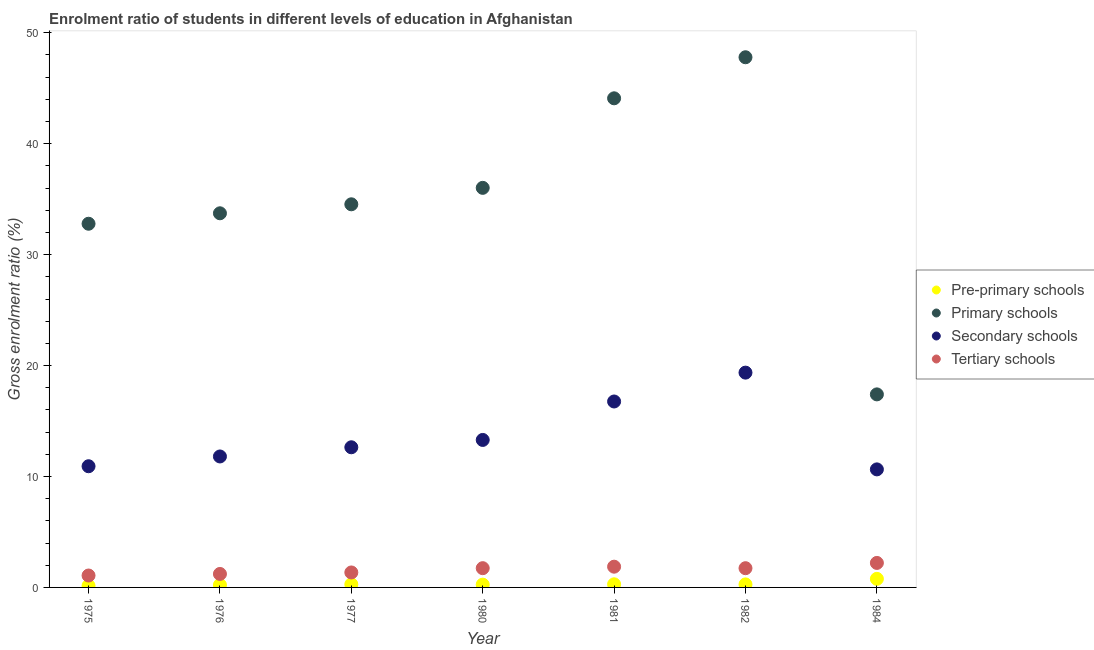How many different coloured dotlines are there?
Your answer should be compact. 4. What is the gross enrolment ratio in primary schools in 1984?
Make the answer very short. 17.4. Across all years, what is the maximum gross enrolment ratio in primary schools?
Keep it short and to the point. 47.8. Across all years, what is the minimum gross enrolment ratio in primary schools?
Offer a very short reply. 17.4. In which year was the gross enrolment ratio in tertiary schools minimum?
Your answer should be very brief. 1975. What is the total gross enrolment ratio in pre-primary schools in the graph?
Your response must be concise. 2.23. What is the difference between the gross enrolment ratio in primary schools in 1976 and that in 1980?
Your response must be concise. -2.29. What is the difference between the gross enrolment ratio in tertiary schools in 1980 and the gross enrolment ratio in primary schools in 1977?
Offer a terse response. -32.8. What is the average gross enrolment ratio in secondary schools per year?
Ensure brevity in your answer.  13.63. In the year 1980, what is the difference between the gross enrolment ratio in primary schools and gross enrolment ratio in secondary schools?
Make the answer very short. 22.73. What is the ratio of the gross enrolment ratio in tertiary schools in 1981 to that in 1982?
Offer a very short reply. 1.08. Is the gross enrolment ratio in primary schools in 1980 less than that in 1982?
Make the answer very short. Yes. What is the difference between the highest and the second highest gross enrolment ratio in tertiary schools?
Offer a very short reply. 0.34. What is the difference between the highest and the lowest gross enrolment ratio in primary schools?
Provide a succinct answer. 30.39. In how many years, is the gross enrolment ratio in secondary schools greater than the average gross enrolment ratio in secondary schools taken over all years?
Offer a very short reply. 2. Is it the case that in every year, the sum of the gross enrolment ratio in tertiary schools and gross enrolment ratio in primary schools is greater than the sum of gross enrolment ratio in secondary schools and gross enrolment ratio in pre-primary schools?
Offer a very short reply. No. Is it the case that in every year, the sum of the gross enrolment ratio in pre-primary schools and gross enrolment ratio in primary schools is greater than the gross enrolment ratio in secondary schools?
Your answer should be compact. Yes. Is the gross enrolment ratio in tertiary schools strictly less than the gross enrolment ratio in secondary schools over the years?
Your response must be concise. Yes. How many dotlines are there?
Your answer should be compact. 4. How many years are there in the graph?
Provide a short and direct response. 7. Does the graph contain any zero values?
Make the answer very short. No. Does the graph contain grids?
Give a very brief answer. No. Where does the legend appear in the graph?
Provide a short and direct response. Center right. How are the legend labels stacked?
Ensure brevity in your answer.  Vertical. What is the title of the graph?
Ensure brevity in your answer.  Enrolment ratio of students in different levels of education in Afghanistan. Does "UNRWA" appear as one of the legend labels in the graph?
Offer a terse response. No. What is the Gross enrolment ratio (%) in Pre-primary schools in 1975?
Provide a succinct answer. 0.15. What is the Gross enrolment ratio (%) of Primary schools in 1975?
Your answer should be compact. 32.79. What is the Gross enrolment ratio (%) of Secondary schools in 1975?
Give a very brief answer. 10.93. What is the Gross enrolment ratio (%) in Tertiary schools in 1975?
Provide a short and direct response. 1.07. What is the Gross enrolment ratio (%) of Pre-primary schools in 1976?
Provide a succinct answer. 0.22. What is the Gross enrolment ratio (%) in Primary schools in 1976?
Your answer should be very brief. 33.73. What is the Gross enrolment ratio (%) of Secondary schools in 1976?
Give a very brief answer. 11.81. What is the Gross enrolment ratio (%) in Tertiary schools in 1976?
Give a very brief answer. 1.22. What is the Gross enrolment ratio (%) in Pre-primary schools in 1977?
Give a very brief answer. 0.28. What is the Gross enrolment ratio (%) of Primary schools in 1977?
Your answer should be compact. 34.54. What is the Gross enrolment ratio (%) of Secondary schools in 1977?
Provide a short and direct response. 12.63. What is the Gross enrolment ratio (%) in Tertiary schools in 1977?
Your response must be concise. 1.35. What is the Gross enrolment ratio (%) of Pre-primary schools in 1980?
Provide a short and direct response. 0.25. What is the Gross enrolment ratio (%) of Primary schools in 1980?
Your answer should be very brief. 36.02. What is the Gross enrolment ratio (%) in Secondary schools in 1980?
Your response must be concise. 13.3. What is the Gross enrolment ratio (%) of Tertiary schools in 1980?
Ensure brevity in your answer.  1.74. What is the Gross enrolment ratio (%) in Pre-primary schools in 1981?
Give a very brief answer. 0.28. What is the Gross enrolment ratio (%) in Primary schools in 1981?
Offer a very short reply. 44.1. What is the Gross enrolment ratio (%) in Secondary schools in 1981?
Give a very brief answer. 16.76. What is the Gross enrolment ratio (%) in Tertiary schools in 1981?
Your answer should be compact. 1.87. What is the Gross enrolment ratio (%) of Pre-primary schools in 1982?
Your answer should be compact. 0.27. What is the Gross enrolment ratio (%) in Primary schools in 1982?
Offer a very short reply. 47.8. What is the Gross enrolment ratio (%) in Secondary schools in 1982?
Your answer should be compact. 19.36. What is the Gross enrolment ratio (%) of Tertiary schools in 1982?
Your answer should be very brief. 1.73. What is the Gross enrolment ratio (%) in Pre-primary schools in 1984?
Provide a succinct answer. 0.77. What is the Gross enrolment ratio (%) of Primary schools in 1984?
Provide a succinct answer. 17.4. What is the Gross enrolment ratio (%) in Secondary schools in 1984?
Make the answer very short. 10.64. What is the Gross enrolment ratio (%) in Tertiary schools in 1984?
Ensure brevity in your answer.  2.21. Across all years, what is the maximum Gross enrolment ratio (%) in Pre-primary schools?
Provide a short and direct response. 0.77. Across all years, what is the maximum Gross enrolment ratio (%) of Primary schools?
Offer a terse response. 47.8. Across all years, what is the maximum Gross enrolment ratio (%) in Secondary schools?
Keep it short and to the point. 19.36. Across all years, what is the maximum Gross enrolment ratio (%) in Tertiary schools?
Provide a succinct answer. 2.21. Across all years, what is the minimum Gross enrolment ratio (%) of Pre-primary schools?
Keep it short and to the point. 0.15. Across all years, what is the minimum Gross enrolment ratio (%) of Primary schools?
Offer a terse response. 17.4. Across all years, what is the minimum Gross enrolment ratio (%) of Secondary schools?
Give a very brief answer. 10.64. Across all years, what is the minimum Gross enrolment ratio (%) in Tertiary schools?
Your response must be concise. 1.07. What is the total Gross enrolment ratio (%) of Pre-primary schools in the graph?
Ensure brevity in your answer.  2.23. What is the total Gross enrolment ratio (%) in Primary schools in the graph?
Your response must be concise. 246.37. What is the total Gross enrolment ratio (%) in Secondary schools in the graph?
Your answer should be compact. 95.43. What is the total Gross enrolment ratio (%) of Tertiary schools in the graph?
Ensure brevity in your answer.  11.19. What is the difference between the Gross enrolment ratio (%) of Pre-primary schools in 1975 and that in 1976?
Keep it short and to the point. -0.07. What is the difference between the Gross enrolment ratio (%) of Primary schools in 1975 and that in 1976?
Offer a terse response. -0.94. What is the difference between the Gross enrolment ratio (%) of Secondary schools in 1975 and that in 1976?
Provide a succinct answer. -0.88. What is the difference between the Gross enrolment ratio (%) in Tertiary schools in 1975 and that in 1976?
Keep it short and to the point. -0.14. What is the difference between the Gross enrolment ratio (%) of Pre-primary schools in 1975 and that in 1977?
Give a very brief answer. -0.13. What is the difference between the Gross enrolment ratio (%) of Primary schools in 1975 and that in 1977?
Offer a terse response. -1.75. What is the difference between the Gross enrolment ratio (%) of Secondary schools in 1975 and that in 1977?
Provide a short and direct response. -1.71. What is the difference between the Gross enrolment ratio (%) in Tertiary schools in 1975 and that in 1977?
Offer a very short reply. -0.28. What is the difference between the Gross enrolment ratio (%) in Pre-primary schools in 1975 and that in 1980?
Provide a succinct answer. -0.1. What is the difference between the Gross enrolment ratio (%) of Primary schools in 1975 and that in 1980?
Provide a succinct answer. -3.24. What is the difference between the Gross enrolment ratio (%) of Secondary schools in 1975 and that in 1980?
Make the answer very short. -2.37. What is the difference between the Gross enrolment ratio (%) in Tertiary schools in 1975 and that in 1980?
Your answer should be compact. -0.66. What is the difference between the Gross enrolment ratio (%) of Pre-primary schools in 1975 and that in 1981?
Ensure brevity in your answer.  -0.13. What is the difference between the Gross enrolment ratio (%) of Primary schools in 1975 and that in 1981?
Your response must be concise. -11.31. What is the difference between the Gross enrolment ratio (%) in Secondary schools in 1975 and that in 1981?
Make the answer very short. -5.84. What is the difference between the Gross enrolment ratio (%) of Tertiary schools in 1975 and that in 1981?
Make the answer very short. -0.8. What is the difference between the Gross enrolment ratio (%) of Pre-primary schools in 1975 and that in 1982?
Offer a very short reply. -0.13. What is the difference between the Gross enrolment ratio (%) of Primary schools in 1975 and that in 1982?
Provide a short and direct response. -15.01. What is the difference between the Gross enrolment ratio (%) in Secondary schools in 1975 and that in 1982?
Your answer should be compact. -8.44. What is the difference between the Gross enrolment ratio (%) of Tertiary schools in 1975 and that in 1982?
Keep it short and to the point. -0.66. What is the difference between the Gross enrolment ratio (%) of Pre-primary schools in 1975 and that in 1984?
Give a very brief answer. -0.62. What is the difference between the Gross enrolment ratio (%) in Primary schools in 1975 and that in 1984?
Provide a short and direct response. 15.38. What is the difference between the Gross enrolment ratio (%) of Secondary schools in 1975 and that in 1984?
Provide a succinct answer. 0.28. What is the difference between the Gross enrolment ratio (%) of Tertiary schools in 1975 and that in 1984?
Keep it short and to the point. -1.13. What is the difference between the Gross enrolment ratio (%) in Pre-primary schools in 1976 and that in 1977?
Your answer should be very brief. -0.06. What is the difference between the Gross enrolment ratio (%) in Primary schools in 1976 and that in 1977?
Provide a succinct answer. -0.81. What is the difference between the Gross enrolment ratio (%) of Secondary schools in 1976 and that in 1977?
Keep it short and to the point. -0.83. What is the difference between the Gross enrolment ratio (%) of Tertiary schools in 1976 and that in 1977?
Ensure brevity in your answer.  -0.13. What is the difference between the Gross enrolment ratio (%) of Pre-primary schools in 1976 and that in 1980?
Keep it short and to the point. -0.03. What is the difference between the Gross enrolment ratio (%) of Primary schools in 1976 and that in 1980?
Your answer should be compact. -2.29. What is the difference between the Gross enrolment ratio (%) of Secondary schools in 1976 and that in 1980?
Keep it short and to the point. -1.49. What is the difference between the Gross enrolment ratio (%) in Tertiary schools in 1976 and that in 1980?
Your answer should be compact. -0.52. What is the difference between the Gross enrolment ratio (%) in Pre-primary schools in 1976 and that in 1981?
Offer a terse response. -0.06. What is the difference between the Gross enrolment ratio (%) in Primary schools in 1976 and that in 1981?
Offer a terse response. -10.37. What is the difference between the Gross enrolment ratio (%) in Secondary schools in 1976 and that in 1981?
Offer a terse response. -4.96. What is the difference between the Gross enrolment ratio (%) of Tertiary schools in 1976 and that in 1981?
Give a very brief answer. -0.65. What is the difference between the Gross enrolment ratio (%) in Pre-primary schools in 1976 and that in 1982?
Offer a very short reply. -0.05. What is the difference between the Gross enrolment ratio (%) of Primary schools in 1976 and that in 1982?
Give a very brief answer. -14.07. What is the difference between the Gross enrolment ratio (%) of Secondary schools in 1976 and that in 1982?
Offer a very short reply. -7.56. What is the difference between the Gross enrolment ratio (%) of Tertiary schools in 1976 and that in 1982?
Keep it short and to the point. -0.52. What is the difference between the Gross enrolment ratio (%) in Pre-primary schools in 1976 and that in 1984?
Keep it short and to the point. -0.55. What is the difference between the Gross enrolment ratio (%) in Primary schools in 1976 and that in 1984?
Provide a succinct answer. 16.33. What is the difference between the Gross enrolment ratio (%) of Secondary schools in 1976 and that in 1984?
Make the answer very short. 1.16. What is the difference between the Gross enrolment ratio (%) in Tertiary schools in 1976 and that in 1984?
Offer a very short reply. -0.99. What is the difference between the Gross enrolment ratio (%) of Pre-primary schools in 1977 and that in 1980?
Your answer should be very brief. 0.03. What is the difference between the Gross enrolment ratio (%) of Primary schools in 1977 and that in 1980?
Provide a succinct answer. -1.48. What is the difference between the Gross enrolment ratio (%) of Secondary schools in 1977 and that in 1980?
Give a very brief answer. -0.66. What is the difference between the Gross enrolment ratio (%) of Tertiary schools in 1977 and that in 1980?
Your answer should be very brief. -0.39. What is the difference between the Gross enrolment ratio (%) of Pre-primary schools in 1977 and that in 1981?
Provide a succinct answer. -0. What is the difference between the Gross enrolment ratio (%) in Primary schools in 1977 and that in 1981?
Your answer should be compact. -9.56. What is the difference between the Gross enrolment ratio (%) of Secondary schools in 1977 and that in 1981?
Keep it short and to the point. -4.13. What is the difference between the Gross enrolment ratio (%) of Tertiary schools in 1977 and that in 1981?
Provide a succinct answer. -0.52. What is the difference between the Gross enrolment ratio (%) in Pre-primary schools in 1977 and that in 1982?
Your answer should be very brief. 0. What is the difference between the Gross enrolment ratio (%) of Primary schools in 1977 and that in 1982?
Ensure brevity in your answer.  -13.26. What is the difference between the Gross enrolment ratio (%) of Secondary schools in 1977 and that in 1982?
Provide a short and direct response. -6.73. What is the difference between the Gross enrolment ratio (%) of Tertiary schools in 1977 and that in 1982?
Offer a terse response. -0.38. What is the difference between the Gross enrolment ratio (%) of Pre-primary schools in 1977 and that in 1984?
Ensure brevity in your answer.  -0.5. What is the difference between the Gross enrolment ratio (%) of Primary schools in 1977 and that in 1984?
Provide a short and direct response. 17.14. What is the difference between the Gross enrolment ratio (%) in Secondary schools in 1977 and that in 1984?
Make the answer very short. 1.99. What is the difference between the Gross enrolment ratio (%) of Tertiary schools in 1977 and that in 1984?
Your response must be concise. -0.86. What is the difference between the Gross enrolment ratio (%) of Pre-primary schools in 1980 and that in 1981?
Your response must be concise. -0.03. What is the difference between the Gross enrolment ratio (%) of Primary schools in 1980 and that in 1981?
Your answer should be very brief. -8.07. What is the difference between the Gross enrolment ratio (%) in Secondary schools in 1980 and that in 1981?
Provide a short and direct response. -3.47. What is the difference between the Gross enrolment ratio (%) of Tertiary schools in 1980 and that in 1981?
Your answer should be very brief. -0.13. What is the difference between the Gross enrolment ratio (%) in Pre-primary schools in 1980 and that in 1982?
Keep it short and to the point. -0.02. What is the difference between the Gross enrolment ratio (%) of Primary schools in 1980 and that in 1982?
Your response must be concise. -11.77. What is the difference between the Gross enrolment ratio (%) of Secondary schools in 1980 and that in 1982?
Make the answer very short. -6.07. What is the difference between the Gross enrolment ratio (%) in Tertiary schools in 1980 and that in 1982?
Your answer should be compact. 0. What is the difference between the Gross enrolment ratio (%) in Pre-primary schools in 1980 and that in 1984?
Ensure brevity in your answer.  -0.52. What is the difference between the Gross enrolment ratio (%) of Primary schools in 1980 and that in 1984?
Keep it short and to the point. 18.62. What is the difference between the Gross enrolment ratio (%) of Secondary schools in 1980 and that in 1984?
Offer a terse response. 2.65. What is the difference between the Gross enrolment ratio (%) of Tertiary schools in 1980 and that in 1984?
Offer a terse response. -0.47. What is the difference between the Gross enrolment ratio (%) in Pre-primary schools in 1981 and that in 1982?
Ensure brevity in your answer.  0.01. What is the difference between the Gross enrolment ratio (%) of Primary schools in 1981 and that in 1982?
Make the answer very short. -3.7. What is the difference between the Gross enrolment ratio (%) of Secondary schools in 1981 and that in 1982?
Offer a terse response. -2.6. What is the difference between the Gross enrolment ratio (%) of Tertiary schools in 1981 and that in 1982?
Your answer should be very brief. 0.14. What is the difference between the Gross enrolment ratio (%) in Pre-primary schools in 1981 and that in 1984?
Offer a terse response. -0.49. What is the difference between the Gross enrolment ratio (%) of Primary schools in 1981 and that in 1984?
Your response must be concise. 26.69. What is the difference between the Gross enrolment ratio (%) of Secondary schools in 1981 and that in 1984?
Offer a very short reply. 6.12. What is the difference between the Gross enrolment ratio (%) in Tertiary schools in 1981 and that in 1984?
Offer a terse response. -0.34. What is the difference between the Gross enrolment ratio (%) in Pre-primary schools in 1982 and that in 1984?
Offer a terse response. -0.5. What is the difference between the Gross enrolment ratio (%) in Primary schools in 1982 and that in 1984?
Offer a very short reply. 30.39. What is the difference between the Gross enrolment ratio (%) in Secondary schools in 1982 and that in 1984?
Offer a terse response. 8.72. What is the difference between the Gross enrolment ratio (%) in Tertiary schools in 1982 and that in 1984?
Your answer should be compact. -0.47. What is the difference between the Gross enrolment ratio (%) in Pre-primary schools in 1975 and the Gross enrolment ratio (%) in Primary schools in 1976?
Offer a terse response. -33.58. What is the difference between the Gross enrolment ratio (%) in Pre-primary schools in 1975 and the Gross enrolment ratio (%) in Secondary schools in 1976?
Your answer should be very brief. -11.66. What is the difference between the Gross enrolment ratio (%) in Pre-primary schools in 1975 and the Gross enrolment ratio (%) in Tertiary schools in 1976?
Your answer should be compact. -1.07. What is the difference between the Gross enrolment ratio (%) in Primary schools in 1975 and the Gross enrolment ratio (%) in Secondary schools in 1976?
Give a very brief answer. 20.98. What is the difference between the Gross enrolment ratio (%) in Primary schools in 1975 and the Gross enrolment ratio (%) in Tertiary schools in 1976?
Make the answer very short. 31.57. What is the difference between the Gross enrolment ratio (%) of Secondary schools in 1975 and the Gross enrolment ratio (%) of Tertiary schools in 1976?
Give a very brief answer. 9.71. What is the difference between the Gross enrolment ratio (%) in Pre-primary schools in 1975 and the Gross enrolment ratio (%) in Primary schools in 1977?
Keep it short and to the point. -34.39. What is the difference between the Gross enrolment ratio (%) of Pre-primary schools in 1975 and the Gross enrolment ratio (%) of Secondary schools in 1977?
Offer a very short reply. -12.49. What is the difference between the Gross enrolment ratio (%) in Pre-primary schools in 1975 and the Gross enrolment ratio (%) in Tertiary schools in 1977?
Ensure brevity in your answer.  -1.2. What is the difference between the Gross enrolment ratio (%) of Primary schools in 1975 and the Gross enrolment ratio (%) of Secondary schools in 1977?
Keep it short and to the point. 20.15. What is the difference between the Gross enrolment ratio (%) of Primary schools in 1975 and the Gross enrolment ratio (%) of Tertiary schools in 1977?
Keep it short and to the point. 31.44. What is the difference between the Gross enrolment ratio (%) of Secondary schools in 1975 and the Gross enrolment ratio (%) of Tertiary schools in 1977?
Ensure brevity in your answer.  9.58. What is the difference between the Gross enrolment ratio (%) of Pre-primary schools in 1975 and the Gross enrolment ratio (%) of Primary schools in 1980?
Provide a short and direct response. -35.87. What is the difference between the Gross enrolment ratio (%) of Pre-primary schools in 1975 and the Gross enrolment ratio (%) of Secondary schools in 1980?
Provide a succinct answer. -13.15. What is the difference between the Gross enrolment ratio (%) in Pre-primary schools in 1975 and the Gross enrolment ratio (%) in Tertiary schools in 1980?
Your answer should be very brief. -1.59. What is the difference between the Gross enrolment ratio (%) in Primary schools in 1975 and the Gross enrolment ratio (%) in Secondary schools in 1980?
Your answer should be very brief. 19.49. What is the difference between the Gross enrolment ratio (%) of Primary schools in 1975 and the Gross enrolment ratio (%) of Tertiary schools in 1980?
Your response must be concise. 31.05. What is the difference between the Gross enrolment ratio (%) of Secondary schools in 1975 and the Gross enrolment ratio (%) of Tertiary schools in 1980?
Provide a succinct answer. 9.19. What is the difference between the Gross enrolment ratio (%) in Pre-primary schools in 1975 and the Gross enrolment ratio (%) in Primary schools in 1981?
Your answer should be very brief. -43.95. What is the difference between the Gross enrolment ratio (%) in Pre-primary schools in 1975 and the Gross enrolment ratio (%) in Secondary schools in 1981?
Make the answer very short. -16.61. What is the difference between the Gross enrolment ratio (%) of Pre-primary schools in 1975 and the Gross enrolment ratio (%) of Tertiary schools in 1981?
Make the answer very short. -1.72. What is the difference between the Gross enrolment ratio (%) of Primary schools in 1975 and the Gross enrolment ratio (%) of Secondary schools in 1981?
Give a very brief answer. 16.02. What is the difference between the Gross enrolment ratio (%) of Primary schools in 1975 and the Gross enrolment ratio (%) of Tertiary schools in 1981?
Make the answer very short. 30.92. What is the difference between the Gross enrolment ratio (%) in Secondary schools in 1975 and the Gross enrolment ratio (%) in Tertiary schools in 1981?
Your answer should be very brief. 9.06. What is the difference between the Gross enrolment ratio (%) of Pre-primary schools in 1975 and the Gross enrolment ratio (%) of Primary schools in 1982?
Provide a short and direct response. -47.65. What is the difference between the Gross enrolment ratio (%) of Pre-primary schools in 1975 and the Gross enrolment ratio (%) of Secondary schools in 1982?
Your answer should be very brief. -19.22. What is the difference between the Gross enrolment ratio (%) in Pre-primary schools in 1975 and the Gross enrolment ratio (%) in Tertiary schools in 1982?
Offer a very short reply. -1.59. What is the difference between the Gross enrolment ratio (%) in Primary schools in 1975 and the Gross enrolment ratio (%) in Secondary schools in 1982?
Offer a very short reply. 13.42. What is the difference between the Gross enrolment ratio (%) of Primary schools in 1975 and the Gross enrolment ratio (%) of Tertiary schools in 1982?
Your response must be concise. 31.05. What is the difference between the Gross enrolment ratio (%) in Secondary schools in 1975 and the Gross enrolment ratio (%) in Tertiary schools in 1982?
Offer a terse response. 9.19. What is the difference between the Gross enrolment ratio (%) of Pre-primary schools in 1975 and the Gross enrolment ratio (%) of Primary schools in 1984?
Offer a terse response. -17.26. What is the difference between the Gross enrolment ratio (%) in Pre-primary schools in 1975 and the Gross enrolment ratio (%) in Secondary schools in 1984?
Make the answer very short. -10.49. What is the difference between the Gross enrolment ratio (%) in Pre-primary schools in 1975 and the Gross enrolment ratio (%) in Tertiary schools in 1984?
Give a very brief answer. -2.06. What is the difference between the Gross enrolment ratio (%) in Primary schools in 1975 and the Gross enrolment ratio (%) in Secondary schools in 1984?
Give a very brief answer. 22.15. What is the difference between the Gross enrolment ratio (%) of Primary schools in 1975 and the Gross enrolment ratio (%) of Tertiary schools in 1984?
Offer a very short reply. 30.58. What is the difference between the Gross enrolment ratio (%) in Secondary schools in 1975 and the Gross enrolment ratio (%) in Tertiary schools in 1984?
Provide a short and direct response. 8.72. What is the difference between the Gross enrolment ratio (%) of Pre-primary schools in 1976 and the Gross enrolment ratio (%) of Primary schools in 1977?
Keep it short and to the point. -34.32. What is the difference between the Gross enrolment ratio (%) in Pre-primary schools in 1976 and the Gross enrolment ratio (%) in Secondary schools in 1977?
Offer a very short reply. -12.41. What is the difference between the Gross enrolment ratio (%) of Pre-primary schools in 1976 and the Gross enrolment ratio (%) of Tertiary schools in 1977?
Provide a short and direct response. -1.13. What is the difference between the Gross enrolment ratio (%) in Primary schools in 1976 and the Gross enrolment ratio (%) in Secondary schools in 1977?
Offer a terse response. 21.09. What is the difference between the Gross enrolment ratio (%) in Primary schools in 1976 and the Gross enrolment ratio (%) in Tertiary schools in 1977?
Give a very brief answer. 32.38. What is the difference between the Gross enrolment ratio (%) of Secondary schools in 1976 and the Gross enrolment ratio (%) of Tertiary schools in 1977?
Keep it short and to the point. 10.46. What is the difference between the Gross enrolment ratio (%) of Pre-primary schools in 1976 and the Gross enrolment ratio (%) of Primary schools in 1980?
Give a very brief answer. -35.8. What is the difference between the Gross enrolment ratio (%) of Pre-primary schools in 1976 and the Gross enrolment ratio (%) of Secondary schools in 1980?
Your answer should be compact. -13.08. What is the difference between the Gross enrolment ratio (%) in Pre-primary schools in 1976 and the Gross enrolment ratio (%) in Tertiary schools in 1980?
Give a very brief answer. -1.52. What is the difference between the Gross enrolment ratio (%) in Primary schools in 1976 and the Gross enrolment ratio (%) in Secondary schools in 1980?
Give a very brief answer. 20.43. What is the difference between the Gross enrolment ratio (%) in Primary schools in 1976 and the Gross enrolment ratio (%) in Tertiary schools in 1980?
Your answer should be very brief. 31.99. What is the difference between the Gross enrolment ratio (%) of Secondary schools in 1976 and the Gross enrolment ratio (%) of Tertiary schools in 1980?
Keep it short and to the point. 10.07. What is the difference between the Gross enrolment ratio (%) of Pre-primary schools in 1976 and the Gross enrolment ratio (%) of Primary schools in 1981?
Give a very brief answer. -43.87. What is the difference between the Gross enrolment ratio (%) in Pre-primary schools in 1976 and the Gross enrolment ratio (%) in Secondary schools in 1981?
Keep it short and to the point. -16.54. What is the difference between the Gross enrolment ratio (%) in Pre-primary schools in 1976 and the Gross enrolment ratio (%) in Tertiary schools in 1981?
Give a very brief answer. -1.65. What is the difference between the Gross enrolment ratio (%) of Primary schools in 1976 and the Gross enrolment ratio (%) of Secondary schools in 1981?
Give a very brief answer. 16.97. What is the difference between the Gross enrolment ratio (%) of Primary schools in 1976 and the Gross enrolment ratio (%) of Tertiary schools in 1981?
Your answer should be compact. 31.86. What is the difference between the Gross enrolment ratio (%) of Secondary schools in 1976 and the Gross enrolment ratio (%) of Tertiary schools in 1981?
Provide a short and direct response. 9.94. What is the difference between the Gross enrolment ratio (%) in Pre-primary schools in 1976 and the Gross enrolment ratio (%) in Primary schools in 1982?
Offer a very short reply. -47.58. What is the difference between the Gross enrolment ratio (%) in Pre-primary schools in 1976 and the Gross enrolment ratio (%) in Secondary schools in 1982?
Your answer should be very brief. -19.14. What is the difference between the Gross enrolment ratio (%) of Pre-primary schools in 1976 and the Gross enrolment ratio (%) of Tertiary schools in 1982?
Offer a very short reply. -1.51. What is the difference between the Gross enrolment ratio (%) of Primary schools in 1976 and the Gross enrolment ratio (%) of Secondary schools in 1982?
Your answer should be compact. 14.36. What is the difference between the Gross enrolment ratio (%) in Primary schools in 1976 and the Gross enrolment ratio (%) in Tertiary schools in 1982?
Provide a succinct answer. 32. What is the difference between the Gross enrolment ratio (%) in Secondary schools in 1976 and the Gross enrolment ratio (%) in Tertiary schools in 1982?
Give a very brief answer. 10.07. What is the difference between the Gross enrolment ratio (%) in Pre-primary schools in 1976 and the Gross enrolment ratio (%) in Primary schools in 1984?
Provide a short and direct response. -17.18. What is the difference between the Gross enrolment ratio (%) in Pre-primary schools in 1976 and the Gross enrolment ratio (%) in Secondary schools in 1984?
Keep it short and to the point. -10.42. What is the difference between the Gross enrolment ratio (%) of Pre-primary schools in 1976 and the Gross enrolment ratio (%) of Tertiary schools in 1984?
Provide a short and direct response. -1.99. What is the difference between the Gross enrolment ratio (%) in Primary schools in 1976 and the Gross enrolment ratio (%) in Secondary schools in 1984?
Your answer should be very brief. 23.09. What is the difference between the Gross enrolment ratio (%) in Primary schools in 1976 and the Gross enrolment ratio (%) in Tertiary schools in 1984?
Make the answer very short. 31.52. What is the difference between the Gross enrolment ratio (%) of Secondary schools in 1976 and the Gross enrolment ratio (%) of Tertiary schools in 1984?
Make the answer very short. 9.6. What is the difference between the Gross enrolment ratio (%) of Pre-primary schools in 1977 and the Gross enrolment ratio (%) of Primary schools in 1980?
Your answer should be very brief. -35.75. What is the difference between the Gross enrolment ratio (%) in Pre-primary schools in 1977 and the Gross enrolment ratio (%) in Secondary schools in 1980?
Your response must be concise. -13.02. What is the difference between the Gross enrolment ratio (%) in Pre-primary schools in 1977 and the Gross enrolment ratio (%) in Tertiary schools in 1980?
Provide a succinct answer. -1.46. What is the difference between the Gross enrolment ratio (%) in Primary schools in 1977 and the Gross enrolment ratio (%) in Secondary schools in 1980?
Offer a very short reply. 21.24. What is the difference between the Gross enrolment ratio (%) of Primary schools in 1977 and the Gross enrolment ratio (%) of Tertiary schools in 1980?
Your answer should be very brief. 32.8. What is the difference between the Gross enrolment ratio (%) in Secondary schools in 1977 and the Gross enrolment ratio (%) in Tertiary schools in 1980?
Give a very brief answer. 10.9. What is the difference between the Gross enrolment ratio (%) in Pre-primary schools in 1977 and the Gross enrolment ratio (%) in Primary schools in 1981?
Ensure brevity in your answer.  -43.82. What is the difference between the Gross enrolment ratio (%) in Pre-primary schools in 1977 and the Gross enrolment ratio (%) in Secondary schools in 1981?
Make the answer very short. -16.49. What is the difference between the Gross enrolment ratio (%) of Pre-primary schools in 1977 and the Gross enrolment ratio (%) of Tertiary schools in 1981?
Your answer should be very brief. -1.59. What is the difference between the Gross enrolment ratio (%) in Primary schools in 1977 and the Gross enrolment ratio (%) in Secondary schools in 1981?
Keep it short and to the point. 17.78. What is the difference between the Gross enrolment ratio (%) in Primary schools in 1977 and the Gross enrolment ratio (%) in Tertiary schools in 1981?
Make the answer very short. 32.67. What is the difference between the Gross enrolment ratio (%) in Secondary schools in 1977 and the Gross enrolment ratio (%) in Tertiary schools in 1981?
Give a very brief answer. 10.76. What is the difference between the Gross enrolment ratio (%) in Pre-primary schools in 1977 and the Gross enrolment ratio (%) in Primary schools in 1982?
Offer a terse response. -47.52. What is the difference between the Gross enrolment ratio (%) in Pre-primary schools in 1977 and the Gross enrolment ratio (%) in Secondary schools in 1982?
Your response must be concise. -19.09. What is the difference between the Gross enrolment ratio (%) in Pre-primary schools in 1977 and the Gross enrolment ratio (%) in Tertiary schools in 1982?
Offer a very short reply. -1.46. What is the difference between the Gross enrolment ratio (%) of Primary schools in 1977 and the Gross enrolment ratio (%) of Secondary schools in 1982?
Offer a very short reply. 15.18. What is the difference between the Gross enrolment ratio (%) in Primary schools in 1977 and the Gross enrolment ratio (%) in Tertiary schools in 1982?
Provide a succinct answer. 32.81. What is the difference between the Gross enrolment ratio (%) of Secondary schools in 1977 and the Gross enrolment ratio (%) of Tertiary schools in 1982?
Keep it short and to the point. 10.9. What is the difference between the Gross enrolment ratio (%) of Pre-primary schools in 1977 and the Gross enrolment ratio (%) of Primary schools in 1984?
Give a very brief answer. -17.13. What is the difference between the Gross enrolment ratio (%) of Pre-primary schools in 1977 and the Gross enrolment ratio (%) of Secondary schools in 1984?
Your response must be concise. -10.36. What is the difference between the Gross enrolment ratio (%) in Pre-primary schools in 1977 and the Gross enrolment ratio (%) in Tertiary schools in 1984?
Keep it short and to the point. -1.93. What is the difference between the Gross enrolment ratio (%) in Primary schools in 1977 and the Gross enrolment ratio (%) in Secondary schools in 1984?
Make the answer very short. 23.9. What is the difference between the Gross enrolment ratio (%) of Primary schools in 1977 and the Gross enrolment ratio (%) of Tertiary schools in 1984?
Provide a short and direct response. 32.33. What is the difference between the Gross enrolment ratio (%) of Secondary schools in 1977 and the Gross enrolment ratio (%) of Tertiary schools in 1984?
Give a very brief answer. 10.43. What is the difference between the Gross enrolment ratio (%) of Pre-primary schools in 1980 and the Gross enrolment ratio (%) of Primary schools in 1981?
Your response must be concise. -43.84. What is the difference between the Gross enrolment ratio (%) of Pre-primary schools in 1980 and the Gross enrolment ratio (%) of Secondary schools in 1981?
Give a very brief answer. -16.51. What is the difference between the Gross enrolment ratio (%) of Pre-primary schools in 1980 and the Gross enrolment ratio (%) of Tertiary schools in 1981?
Ensure brevity in your answer.  -1.62. What is the difference between the Gross enrolment ratio (%) of Primary schools in 1980 and the Gross enrolment ratio (%) of Secondary schools in 1981?
Give a very brief answer. 19.26. What is the difference between the Gross enrolment ratio (%) in Primary schools in 1980 and the Gross enrolment ratio (%) in Tertiary schools in 1981?
Your answer should be compact. 34.15. What is the difference between the Gross enrolment ratio (%) in Secondary schools in 1980 and the Gross enrolment ratio (%) in Tertiary schools in 1981?
Make the answer very short. 11.43. What is the difference between the Gross enrolment ratio (%) in Pre-primary schools in 1980 and the Gross enrolment ratio (%) in Primary schools in 1982?
Make the answer very short. -47.54. What is the difference between the Gross enrolment ratio (%) in Pre-primary schools in 1980 and the Gross enrolment ratio (%) in Secondary schools in 1982?
Provide a succinct answer. -19.11. What is the difference between the Gross enrolment ratio (%) of Pre-primary schools in 1980 and the Gross enrolment ratio (%) of Tertiary schools in 1982?
Offer a terse response. -1.48. What is the difference between the Gross enrolment ratio (%) in Primary schools in 1980 and the Gross enrolment ratio (%) in Secondary schools in 1982?
Your response must be concise. 16.66. What is the difference between the Gross enrolment ratio (%) of Primary schools in 1980 and the Gross enrolment ratio (%) of Tertiary schools in 1982?
Your response must be concise. 34.29. What is the difference between the Gross enrolment ratio (%) in Secondary schools in 1980 and the Gross enrolment ratio (%) in Tertiary schools in 1982?
Give a very brief answer. 11.56. What is the difference between the Gross enrolment ratio (%) of Pre-primary schools in 1980 and the Gross enrolment ratio (%) of Primary schools in 1984?
Ensure brevity in your answer.  -17.15. What is the difference between the Gross enrolment ratio (%) of Pre-primary schools in 1980 and the Gross enrolment ratio (%) of Secondary schools in 1984?
Your response must be concise. -10.39. What is the difference between the Gross enrolment ratio (%) in Pre-primary schools in 1980 and the Gross enrolment ratio (%) in Tertiary schools in 1984?
Offer a terse response. -1.96. What is the difference between the Gross enrolment ratio (%) in Primary schools in 1980 and the Gross enrolment ratio (%) in Secondary schools in 1984?
Your response must be concise. 25.38. What is the difference between the Gross enrolment ratio (%) in Primary schools in 1980 and the Gross enrolment ratio (%) in Tertiary schools in 1984?
Your answer should be compact. 33.81. What is the difference between the Gross enrolment ratio (%) in Secondary schools in 1980 and the Gross enrolment ratio (%) in Tertiary schools in 1984?
Keep it short and to the point. 11.09. What is the difference between the Gross enrolment ratio (%) of Pre-primary schools in 1981 and the Gross enrolment ratio (%) of Primary schools in 1982?
Keep it short and to the point. -47.51. What is the difference between the Gross enrolment ratio (%) in Pre-primary schools in 1981 and the Gross enrolment ratio (%) in Secondary schools in 1982?
Provide a short and direct response. -19.08. What is the difference between the Gross enrolment ratio (%) in Pre-primary schools in 1981 and the Gross enrolment ratio (%) in Tertiary schools in 1982?
Offer a terse response. -1.45. What is the difference between the Gross enrolment ratio (%) of Primary schools in 1981 and the Gross enrolment ratio (%) of Secondary schools in 1982?
Make the answer very short. 24.73. What is the difference between the Gross enrolment ratio (%) in Primary schools in 1981 and the Gross enrolment ratio (%) in Tertiary schools in 1982?
Keep it short and to the point. 42.36. What is the difference between the Gross enrolment ratio (%) of Secondary schools in 1981 and the Gross enrolment ratio (%) of Tertiary schools in 1982?
Your answer should be very brief. 15.03. What is the difference between the Gross enrolment ratio (%) in Pre-primary schools in 1981 and the Gross enrolment ratio (%) in Primary schools in 1984?
Provide a short and direct response. -17.12. What is the difference between the Gross enrolment ratio (%) of Pre-primary schools in 1981 and the Gross enrolment ratio (%) of Secondary schools in 1984?
Give a very brief answer. -10.36. What is the difference between the Gross enrolment ratio (%) of Pre-primary schools in 1981 and the Gross enrolment ratio (%) of Tertiary schools in 1984?
Provide a succinct answer. -1.93. What is the difference between the Gross enrolment ratio (%) of Primary schools in 1981 and the Gross enrolment ratio (%) of Secondary schools in 1984?
Provide a short and direct response. 33.45. What is the difference between the Gross enrolment ratio (%) in Primary schools in 1981 and the Gross enrolment ratio (%) in Tertiary schools in 1984?
Your answer should be very brief. 41.89. What is the difference between the Gross enrolment ratio (%) of Secondary schools in 1981 and the Gross enrolment ratio (%) of Tertiary schools in 1984?
Offer a very short reply. 14.55. What is the difference between the Gross enrolment ratio (%) in Pre-primary schools in 1982 and the Gross enrolment ratio (%) in Primary schools in 1984?
Give a very brief answer. -17.13. What is the difference between the Gross enrolment ratio (%) in Pre-primary schools in 1982 and the Gross enrolment ratio (%) in Secondary schools in 1984?
Your answer should be very brief. -10.37. What is the difference between the Gross enrolment ratio (%) in Pre-primary schools in 1982 and the Gross enrolment ratio (%) in Tertiary schools in 1984?
Your response must be concise. -1.94. What is the difference between the Gross enrolment ratio (%) of Primary schools in 1982 and the Gross enrolment ratio (%) of Secondary schools in 1984?
Provide a short and direct response. 37.15. What is the difference between the Gross enrolment ratio (%) of Primary schools in 1982 and the Gross enrolment ratio (%) of Tertiary schools in 1984?
Your answer should be very brief. 45.59. What is the difference between the Gross enrolment ratio (%) of Secondary schools in 1982 and the Gross enrolment ratio (%) of Tertiary schools in 1984?
Provide a succinct answer. 17.16. What is the average Gross enrolment ratio (%) in Pre-primary schools per year?
Your answer should be compact. 0.32. What is the average Gross enrolment ratio (%) in Primary schools per year?
Your response must be concise. 35.2. What is the average Gross enrolment ratio (%) of Secondary schools per year?
Your answer should be very brief. 13.63. What is the average Gross enrolment ratio (%) in Tertiary schools per year?
Provide a succinct answer. 1.6. In the year 1975, what is the difference between the Gross enrolment ratio (%) in Pre-primary schools and Gross enrolment ratio (%) in Primary schools?
Make the answer very short. -32.64. In the year 1975, what is the difference between the Gross enrolment ratio (%) in Pre-primary schools and Gross enrolment ratio (%) in Secondary schools?
Ensure brevity in your answer.  -10.78. In the year 1975, what is the difference between the Gross enrolment ratio (%) of Pre-primary schools and Gross enrolment ratio (%) of Tertiary schools?
Provide a succinct answer. -0.93. In the year 1975, what is the difference between the Gross enrolment ratio (%) in Primary schools and Gross enrolment ratio (%) in Secondary schools?
Ensure brevity in your answer.  21.86. In the year 1975, what is the difference between the Gross enrolment ratio (%) in Primary schools and Gross enrolment ratio (%) in Tertiary schools?
Your response must be concise. 31.71. In the year 1975, what is the difference between the Gross enrolment ratio (%) in Secondary schools and Gross enrolment ratio (%) in Tertiary schools?
Provide a short and direct response. 9.85. In the year 1976, what is the difference between the Gross enrolment ratio (%) of Pre-primary schools and Gross enrolment ratio (%) of Primary schools?
Give a very brief answer. -33.51. In the year 1976, what is the difference between the Gross enrolment ratio (%) in Pre-primary schools and Gross enrolment ratio (%) in Secondary schools?
Provide a succinct answer. -11.59. In the year 1976, what is the difference between the Gross enrolment ratio (%) of Pre-primary schools and Gross enrolment ratio (%) of Tertiary schools?
Keep it short and to the point. -1. In the year 1976, what is the difference between the Gross enrolment ratio (%) in Primary schools and Gross enrolment ratio (%) in Secondary schools?
Provide a short and direct response. 21.92. In the year 1976, what is the difference between the Gross enrolment ratio (%) of Primary schools and Gross enrolment ratio (%) of Tertiary schools?
Ensure brevity in your answer.  32.51. In the year 1976, what is the difference between the Gross enrolment ratio (%) of Secondary schools and Gross enrolment ratio (%) of Tertiary schools?
Ensure brevity in your answer.  10.59. In the year 1977, what is the difference between the Gross enrolment ratio (%) in Pre-primary schools and Gross enrolment ratio (%) in Primary schools?
Provide a succinct answer. -34.26. In the year 1977, what is the difference between the Gross enrolment ratio (%) in Pre-primary schools and Gross enrolment ratio (%) in Secondary schools?
Give a very brief answer. -12.36. In the year 1977, what is the difference between the Gross enrolment ratio (%) of Pre-primary schools and Gross enrolment ratio (%) of Tertiary schools?
Give a very brief answer. -1.07. In the year 1977, what is the difference between the Gross enrolment ratio (%) of Primary schools and Gross enrolment ratio (%) of Secondary schools?
Your response must be concise. 21.91. In the year 1977, what is the difference between the Gross enrolment ratio (%) in Primary schools and Gross enrolment ratio (%) in Tertiary schools?
Give a very brief answer. 33.19. In the year 1977, what is the difference between the Gross enrolment ratio (%) of Secondary schools and Gross enrolment ratio (%) of Tertiary schools?
Your answer should be compact. 11.28. In the year 1980, what is the difference between the Gross enrolment ratio (%) in Pre-primary schools and Gross enrolment ratio (%) in Primary schools?
Ensure brevity in your answer.  -35.77. In the year 1980, what is the difference between the Gross enrolment ratio (%) of Pre-primary schools and Gross enrolment ratio (%) of Secondary schools?
Your answer should be very brief. -13.04. In the year 1980, what is the difference between the Gross enrolment ratio (%) of Pre-primary schools and Gross enrolment ratio (%) of Tertiary schools?
Provide a short and direct response. -1.48. In the year 1980, what is the difference between the Gross enrolment ratio (%) in Primary schools and Gross enrolment ratio (%) in Secondary schools?
Your answer should be compact. 22.73. In the year 1980, what is the difference between the Gross enrolment ratio (%) of Primary schools and Gross enrolment ratio (%) of Tertiary schools?
Give a very brief answer. 34.29. In the year 1980, what is the difference between the Gross enrolment ratio (%) of Secondary schools and Gross enrolment ratio (%) of Tertiary schools?
Offer a very short reply. 11.56. In the year 1981, what is the difference between the Gross enrolment ratio (%) of Pre-primary schools and Gross enrolment ratio (%) of Primary schools?
Give a very brief answer. -43.81. In the year 1981, what is the difference between the Gross enrolment ratio (%) in Pre-primary schools and Gross enrolment ratio (%) in Secondary schools?
Provide a short and direct response. -16.48. In the year 1981, what is the difference between the Gross enrolment ratio (%) of Pre-primary schools and Gross enrolment ratio (%) of Tertiary schools?
Your answer should be very brief. -1.59. In the year 1981, what is the difference between the Gross enrolment ratio (%) in Primary schools and Gross enrolment ratio (%) in Secondary schools?
Offer a very short reply. 27.33. In the year 1981, what is the difference between the Gross enrolment ratio (%) of Primary schools and Gross enrolment ratio (%) of Tertiary schools?
Provide a succinct answer. 42.23. In the year 1981, what is the difference between the Gross enrolment ratio (%) in Secondary schools and Gross enrolment ratio (%) in Tertiary schools?
Provide a short and direct response. 14.89. In the year 1982, what is the difference between the Gross enrolment ratio (%) in Pre-primary schools and Gross enrolment ratio (%) in Primary schools?
Your answer should be compact. -47.52. In the year 1982, what is the difference between the Gross enrolment ratio (%) in Pre-primary schools and Gross enrolment ratio (%) in Secondary schools?
Ensure brevity in your answer.  -19.09. In the year 1982, what is the difference between the Gross enrolment ratio (%) of Pre-primary schools and Gross enrolment ratio (%) of Tertiary schools?
Make the answer very short. -1.46. In the year 1982, what is the difference between the Gross enrolment ratio (%) of Primary schools and Gross enrolment ratio (%) of Secondary schools?
Provide a short and direct response. 28.43. In the year 1982, what is the difference between the Gross enrolment ratio (%) in Primary schools and Gross enrolment ratio (%) in Tertiary schools?
Offer a very short reply. 46.06. In the year 1982, what is the difference between the Gross enrolment ratio (%) of Secondary schools and Gross enrolment ratio (%) of Tertiary schools?
Provide a succinct answer. 17.63. In the year 1984, what is the difference between the Gross enrolment ratio (%) in Pre-primary schools and Gross enrolment ratio (%) in Primary schools?
Give a very brief answer. -16.63. In the year 1984, what is the difference between the Gross enrolment ratio (%) in Pre-primary schools and Gross enrolment ratio (%) in Secondary schools?
Your response must be concise. -9.87. In the year 1984, what is the difference between the Gross enrolment ratio (%) of Pre-primary schools and Gross enrolment ratio (%) of Tertiary schools?
Make the answer very short. -1.44. In the year 1984, what is the difference between the Gross enrolment ratio (%) of Primary schools and Gross enrolment ratio (%) of Secondary schools?
Make the answer very short. 6.76. In the year 1984, what is the difference between the Gross enrolment ratio (%) in Primary schools and Gross enrolment ratio (%) in Tertiary schools?
Give a very brief answer. 15.2. In the year 1984, what is the difference between the Gross enrolment ratio (%) of Secondary schools and Gross enrolment ratio (%) of Tertiary schools?
Offer a very short reply. 8.43. What is the ratio of the Gross enrolment ratio (%) of Pre-primary schools in 1975 to that in 1976?
Offer a very short reply. 0.67. What is the ratio of the Gross enrolment ratio (%) in Primary schools in 1975 to that in 1976?
Provide a short and direct response. 0.97. What is the ratio of the Gross enrolment ratio (%) in Secondary schools in 1975 to that in 1976?
Give a very brief answer. 0.93. What is the ratio of the Gross enrolment ratio (%) of Tertiary schools in 1975 to that in 1976?
Your answer should be very brief. 0.88. What is the ratio of the Gross enrolment ratio (%) in Pre-primary schools in 1975 to that in 1977?
Provide a succinct answer. 0.53. What is the ratio of the Gross enrolment ratio (%) of Primary schools in 1975 to that in 1977?
Keep it short and to the point. 0.95. What is the ratio of the Gross enrolment ratio (%) of Secondary schools in 1975 to that in 1977?
Your answer should be very brief. 0.86. What is the ratio of the Gross enrolment ratio (%) in Tertiary schools in 1975 to that in 1977?
Your response must be concise. 0.8. What is the ratio of the Gross enrolment ratio (%) of Pre-primary schools in 1975 to that in 1980?
Provide a short and direct response. 0.59. What is the ratio of the Gross enrolment ratio (%) of Primary schools in 1975 to that in 1980?
Ensure brevity in your answer.  0.91. What is the ratio of the Gross enrolment ratio (%) of Secondary schools in 1975 to that in 1980?
Provide a succinct answer. 0.82. What is the ratio of the Gross enrolment ratio (%) of Tertiary schools in 1975 to that in 1980?
Keep it short and to the point. 0.62. What is the ratio of the Gross enrolment ratio (%) in Pre-primary schools in 1975 to that in 1981?
Give a very brief answer. 0.52. What is the ratio of the Gross enrolment ratio (%) of Primary schools in 1975 to that in 1981?
Provide a succinct answer. 0.74. What is the ratio of the Gross enrolment ratio (%) in Secondary schools in 1975 to that in 1981?
Your response must be concise. 0.65. What is the ratio of the Gross enrolment ratio (%) of Tertiary schools in 1975 to that in 1981?
Your answer should be very brief. 0.57. What is the ratio of the Gross enrolment ratio (%) in Pre-primary schools in 1975 to that in 1982?
Make the answer very short. 0.54. What is the ratio of the Gross enrolment ratio (%) in Primary schools in 1975 to that in 1982?
Provide a short and direct response. 0.69. What is the ratio of the Gross enrolment ratio (%) of Secondary schools in 1975 to that in 1982?
Keep it short and to the point. 0.56. What is the ratio of the Gross enrolment ratio (%) in Tertiary schools in 1975 to that in 1982?
Your answer should be compact. 0.62. What is the ratio of the Gross enrolment ratio (%) in Pre-primary schools in 1975 to that in 1984?
Give a very brief answer. 0.19. What is the ratio of the Gross enrolment ratio (%) of Primary schools in 1975 to that in 1984?
Your answer should be compact. 1.88. What is the ratio of the Gross enrolment ratio (%) of Secondary schools in 1975 to that in 1984?
Give a very brief answer. 1.03. What is the ratio of the Gross enrolment ratio (%) in Tertiary schools in 1975 to that in 1984?
Your answer should be compact. 0.49. What is the ratio of the Gross enrolment ratio (%) in Pre-primary schools in 1976 to that in 1977?
Offer a terse response. 0.79. What is the ratio of the Gross enrolment ratio (%) in Primary schools in 1976 to that in 1977?
Provide a succinct answer. 0.98. What is the ratio of the Gross enrolment ratio (%) in Secondary schools in 1976 to that in 1977?
Provide a short and direct response. 0.93. What is the ratio of the Gross enrolment ratio (%) in Tertiary schools in 1976 to that in 1977?
Provide a short and direct response. 0.9. What is the ratio of the Gross enrolment ratio (%) of Pre-primary schools in 1976 to that in 1980?
Ensure brevity in your answer.  0.87. What is the ratio of the Gross enrolment ratio (%) of Primary schools in 1976 to that in 1980?
Make the answer very short. 0.94. What is the ratio of the Gross enrolment ratio (%) in Secondary schools in 1976 to that in 1980?
Offer a terse response. 0.89. What is the ratio of the Gross enrolment ratio (%) of Tertiary schools in 1976 to that in 1980?
Offer a terse response. 0.7. What is the ratio of the Gross enrolment ratio (%) in Pre-primary schools in 1976 to that in 1981?
Offer a very short reply. 0.78. What is the ratio of the Gross enrolment ratio (%) in Primary schools in 1976 to that in 1981?
Provide a succinct answer. 0.76. What is the ratio of the Gross enrolment ratio (%) of Secondary schools in 1976 to that in 1981?
Your answer should be compact. 0.7. What is the ratio of the Gross enrolment ratio (%) in Tertiary schools in 1976 to that in 1981?
Your answer should be very brief. 0.65. What is the ratio of the Gross enrolment ratio (%) of Pre-primary schools in 1976 to that in 1982?
Give a very brief answer. 0.81. What is the ratio of the Gross enrolment ratio (%) of Primary schools in 1976 to that in 1982?
Your answer should be compact. 0.71. What is the ratio of the Gross enrolment ratio (%) of Secondary schools in 1976 to that in 1982?
Provide a succinct answer. 0.61. What is the ratio of the Gross enrolment ratio (%) of Tertiary schools in 1976 to that in 1982?
Provide a short and direct response. 0.7. What is the ratio of the Gross enrolment ratio (%) of Pre-primary schools in 1976 to that in 1984?
Provide a short and direct response. 0.28. What is the ratio of the Gross enrolment ratio (%) of Primary schools in 1976 to that in 1984?
Offer a terse response. 1.94. What is the ratio of the Gross enrolment ratio (%) in Secondary schools in 1976 to that in 1984?
Provide a succinct answer. 1.11. What is the ratio of the Gross enrolment ratio (%) of Tertiary schools in 1976 to that in 1984?
Provide a succinct answer. 0.55. What is the ratio of the Gross enrolment ratio (%) of Pre-primary schools in 1977 to that in 1980?
Your answer should be compact. 1.1. What is the ratio of the Gross enrolment ratio (%) in Primary schools in 1977 to that in 1980?
Ensure brevity in your answer.  0.96. What is the ratio of the Gross enrolment ratio (%) of Secondary schools in 1977 to that in 1980?
Provide a succinct answer. 0.95. What is the ratio of the Gross enrolment ratio (%) of Tertiary schools in 1977 to that in 1980?
Your response must be concise. 0.78. What is the ratio of the Gross enrolment ratio (%) of Pre-primary schools in 1977 to that in 1981?
Keep it short and to the point. 0.98. What is the ratio of the Gross enrolment ratio (%) in Primary schools in 1977 to that in 1981?
Keep it short and to the point. 0.78. What is the ratio of the Gross enrolment ratio (%) of Secondary schools in 1977 to that in 1981?
Your response must be concise. 0.75. What is the ratio of the Gross enrolment ratio (%) in Tertiary schools in 1977 to that in 1981?
Your answer should be compact. 0.72. What is the ratio of the Gross enrolment ratio (%) in Pre-primary schools in 1977 to that in 1982?
Your answer should be very brief. 1.02. What is the ratio of the Gross enrolment ratio (%) in Primary schools in 1977 to that in 1982?
Provide a short and direct response. 0.72. What is the ratio of the Gross enrolment ratio (%) of Secondary schools in 1977 to that in 1982?
Ensure brevity in your answer.  0.65. What is the ratio of the Gross enrolment ratio (%) in Tertiary schools in 1977 to that in 1982?
Offer a very short reply. 0.78. What is the ratio of the Gross enrolment ratio (%) of Pre-primary schools in 1977 to that in 1984?
Keep it short and to the point. 0.36. What is the ratio of the Gross enrolment ratio (%) in Primary schools in 1977 to that in 1984?
Keep it short and to the point. 1.98. What is the ratio of the Gross enrolment ratio (%) in Secondary schools in 1977 to that in 1984?
Make the answer very short. 1.19. What is the ratio of the Gross enrolment ratio (%) of Tertiary schools in 1977 to that in 1984?
Keep it short and to the point. 0.61. What is the ratio of the Gross enrolment ratio (%) of Pre-primary schools in 1980 to that in 1981?
Give a very brief answer. 0.89. What is the ratio of the Gross enrolment ratio (%) in Primary schools in 1980 to that in 1981?
Give a very brief answer. 0.82. What is the ratio of the Gross enrolment ratio (%) in Secondary schools in 1980 to that in 1981?
Ensure brevity in your answer.  0.79. What is the ratio of the Gross enrolment ratio (%) of Tertiary schools in 1980 to that in 1981?
Your answer should be compact. 0.93. What is the ratio of the Gross enrolment ratio (%) in Pre-primary schools in 1980 to that in 1982?
Make the answer very short. 0.92. What is the ratio of the Gross enrolment ratio (%) of Primary schools in 1980 to that in 1982?
Your answer should be compact. 0.75. What is the ratio of the Gross enrolment ratio (%) in Secondary schools in 1980 to that in 1982?
Make the answer very short. 0.69. What is the ratio of the Gross enrolment ratio (%) of Pre-primary schools in 1980 to that in 1984?
Your answer should be compact. 0.33. What is the ratio of the Gross enrolment ratio (%) in Primary schools in 1980 to that in 1984?
Your answer should be compact. 2.07. What is the ratio of the Gross enrolment ratio (%) of Secondary schools in 1980 to that in 1984?
Offer a very short reply. 1.25. What is the ratio of the Gross enrolment ratio (%) in Tertiary schools in 1980 to that in 1984?
Make the answer very short. 0.79. What is the ratio of the Gross enrolment ratio (%) in Pre-primary schools in 1981 to that in 1982?
Provide a succinct answer. 1.03. What is the ratio of the Gross enrolment ratio (%) in Primary schools in 1981 to that in 1982?
Ensure brevity in your answer.  0.92. What is the ratio of the Gross enrolment ratio (%) in Secondary schools in 1981 to that in 1982?
Ensure brevity in your answer.  0.87. What is the ratio of the Gross enrolment ratio (%) of Tertiary schools in 1981 to that in 1982?
Ensure brevity in your answer.  1.08. What is the ratio of the Gross enrolment ratio (%) of Pre-primary schools in 1981 to that in 1984?
Offer a very short reply. 0.37. What is the ratio of the Gross enrolment ratio (%) of Primary schools in 1981 to that in 1984?
Offer a very short reply. 2.53. What is the ratio of the Gross enrolment ratio (%) in Secondary schools in 1981 to that in 1984?
Your response must be concise. 1.58. What is the ratio of the Gross enrolment ratio (%) of Tertiary schools in 1981 to that in 1984?
Your response must be concise. 0.85. What is the ratio of the Gross enrolment ratio (%) of Pre-primary schools in 1982 to that in 1984?
Your answer should be compact. 0.35. What is the ratio of the Gross enrolment ratio (%) of Primary schools in 1982 to that in 1984?
Your response must be concise. 2.75. What is the ratio of the Gross enrolment ratio (%) of Secondary schools in 1982 to that in 1984?
Offer a very short reply. 1.82. What is the ratio of the Gross enrolment ratio (%) of Tertiary schools in 1982 to that in 1984?
Give a very brief answer. 0.78. What is the difference between the highest and the second highest Gross enrolment ratio (%) in Pre-primary schools?
Ensure brevity in your answer.  0.49. What is the difference between the highest and the second highest Gross enrolment ratio (%) in Primary schools?
Provide a succinct answer. 3.7. What is the difference between the highest and the second highest Gross enrolment ratio (%) of Secondary schools?
Keep it short and to the point. 2.6. What is the difference between the highest and the second highest Gross enrolment ratio (%) in Tertiary schools?
Your response must be concise. 0.34. What is the difference between the highest and the lowest Gross enrolment ratio (%) of Pre-primary schools?
Ensure brevity in your answer.  0.62. What is the difference between the highest and the lowest Gross enrolment ratio (%) of Primary schools?
Ensure brevity in your answer.  30.39. What is the difference between the highest and the lowest Gross enrolment ratio (%) in Secondary schools?
Provide a succinct answer. 8.72. What is the difference between the highest and the lowest Gross enrolment ratio (%) of Tertiary schools?
Your answer should be very brief. 1.13. 